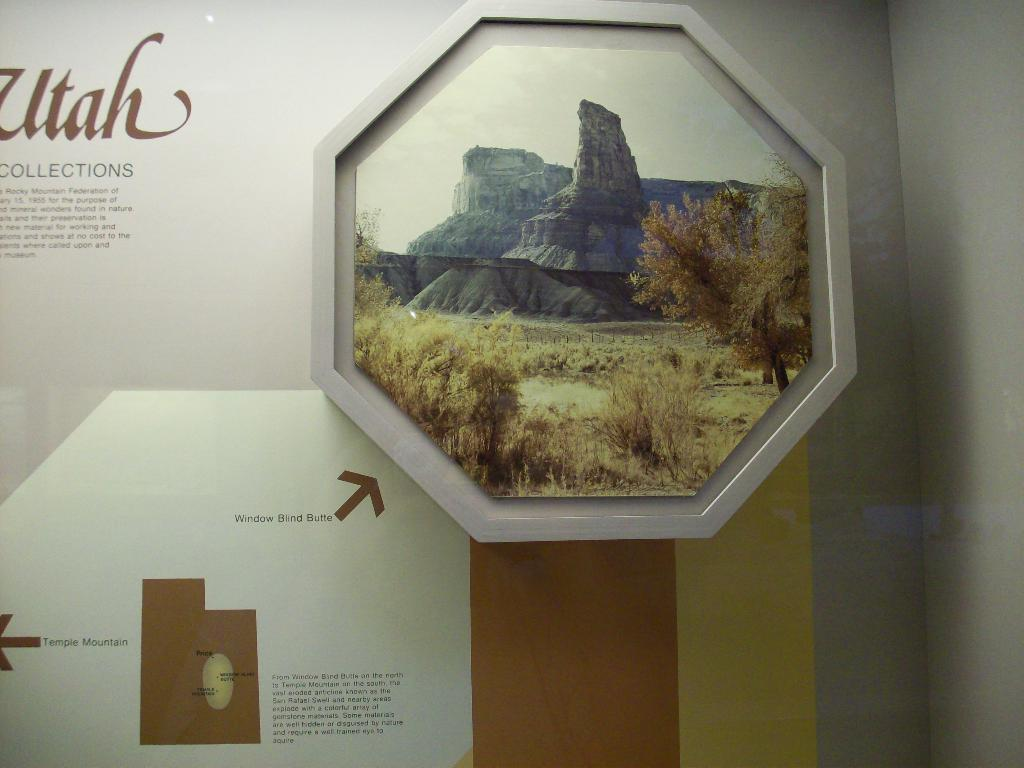What is on the wall in the image? There is text on the wall in the image. What else can be seen in the image besides the text? There is a frame in the image. What is depicted within the frame? The frame contains a depiction of trees, rocks, and the sky. Is there a hospital depicted within the frame in the image? No, there is no hospital depicted within the frame in the image. The frame contains a depiction of trees, rocks, and the sky. Can you tell me how much respect the rocks have for the trees in the image? The image does not convey any information about the level of respect between the rocks and trees, as it is a static representation. 